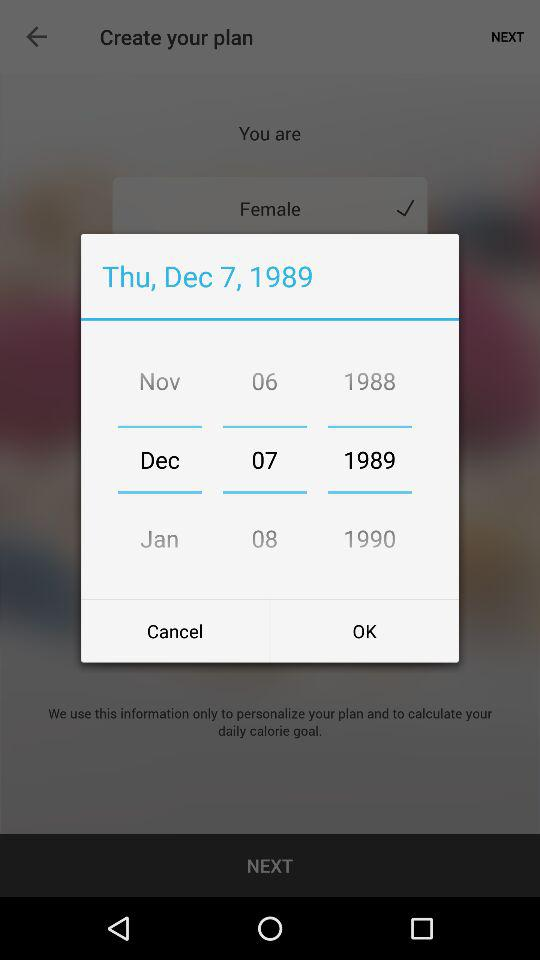What is the selected date? The selected date is December 7, 1989. 